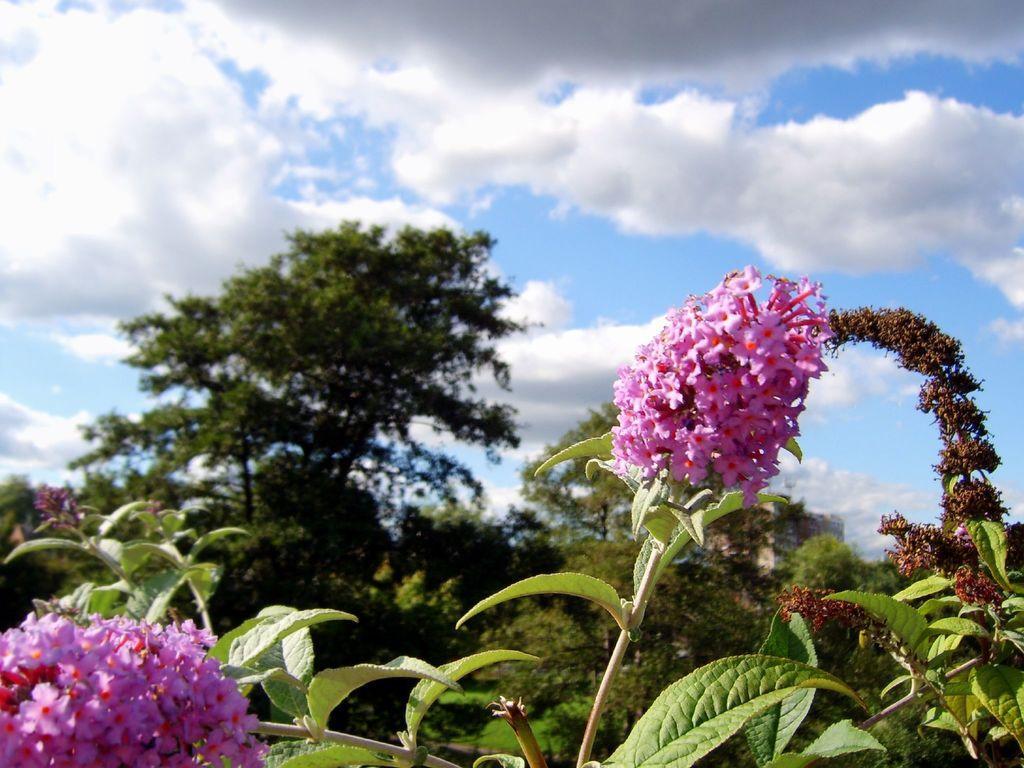How would you summarize this image in a sentence or two? In this image we can see sky with clouds, trees, plants and flowers. 